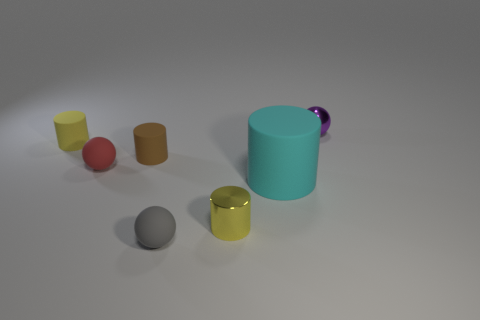Subtract all red spheres. How many spheres are left? 2 Add 3 metal cylinders. How many objects exist? 10 Subtract all red balls. How many balls are left? 2 Subtract all cylinders. How many objects are left? 3 Subtract 2 cylinders. How many cylinders are left? 2 Subtract all cyan cylinders. Subtract all green balls. How many cylinders are left? 3 Subtract all purple balls. How many red cylinders are left? 0 Subtract all big cyan rubber cylinders. Subtract all metallic spheres. How many objects are left? 5 Add 1 small yellow rubber things. How many small yellow rubber things are left? 2 Add 4 brown rubber cylinders. How many brown rubber cylinders exist? 5 